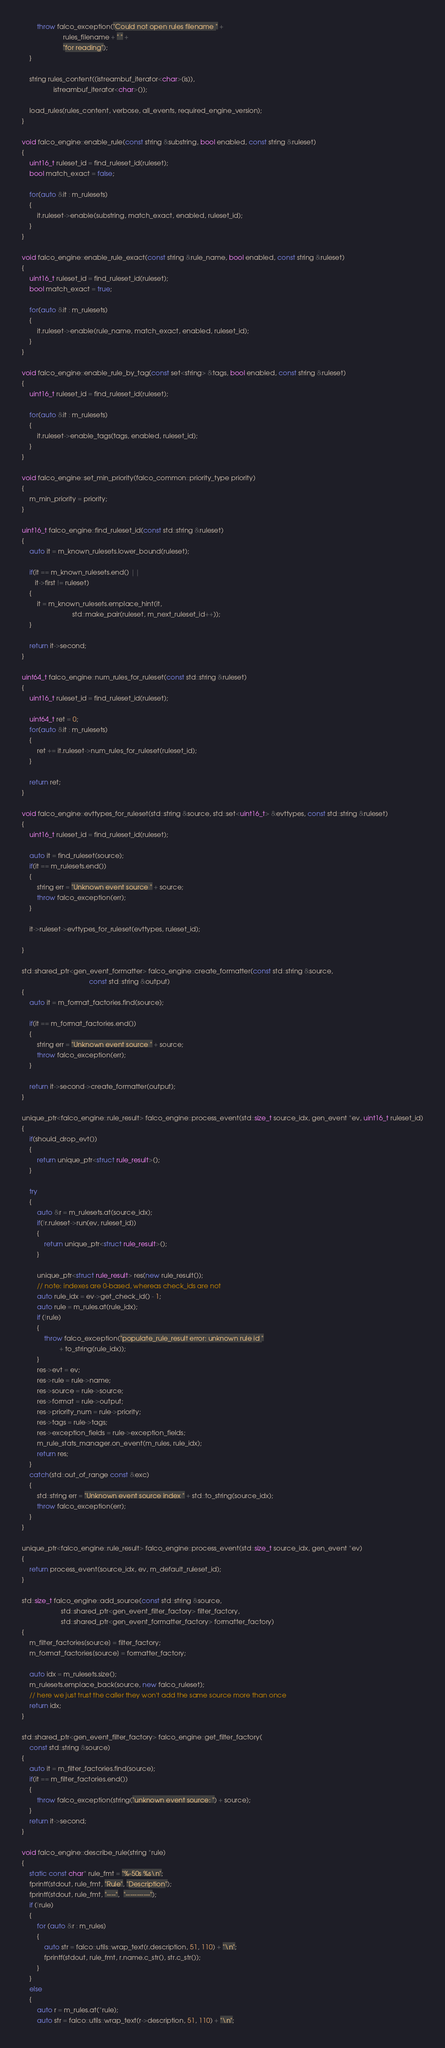Convert code to text. <code><loc_0><loc_0><loc_500><loc_500><_C++_>		throw falco_exception("Could not open rules filename " +
				      rules_filename + " " +
				      "for reading");
	}

	string rules_content((istreambuf_iterator<char>(is)),
			     istreambuf_iterator<char>());

	load_rules(rules_content, verbose, all_events, required_engine_version);
}

void falco_engine::enable_rule(const string &substring, bool enabled, const string &ruleset)
{
	uint16_t ruleset_id = find_ruleset_id(ruleset);
	bool match_exact = false;

	for(auto &it : m_rulesets)
	{
		it.ruleset->enable(substring, match_exact, enabled, ruleset_id);
	}
}

void falco_engine::enable_rule_exact(const string &rule_name, bool enabled, const string &ruleset)
{
	uint16_t ruleset_id = find_ruleset_id(ruleset);
	bool match_exact = true;

	for(auto &it : m_rulesets)
	{
		it.ruleset->enable(rule_name, match_exact, enabled, ruleset_id);
	}
}

void falco_engine::enable_rule_by_tag(const set<string> &tags, bool enabled, const string &ruleset)
{
	uint16_t ruleset_id = find_ruleset_id(ruleset);

	for(auto &it : m_rulesets)
	{
		it.ruleset->enable_tags(tags, enabled, ruleset_id);
	}
}

void falco_engine::set_min_priority(falco_common::priority_type priority)
{
	m_min_priority = priority;
}

uint16_t falco_engine::find_ruleset_id(const std::string &ruleset)
{
	auto it = m_known_rulesets.lower_bound(ruleset);

	if(it == m_known_rulesets.end() ||
	   it->first != ruleset)
	{
		it = m_known_rulesets.emplace_hint(it,
						   std::make_pair(ruleset, m_next_ruleset_id++));
	}

	return it->second;
}

uint64_t falco_engine::num_rules_for_ruleset(const std::string &ruleset)
{
	uint16_t ruleset_id = find_ruleset_id(ruleset);

	uint64_t ret = 0;
	for(auto &it : m_rulesets)
	{
		ret += it.ruleset->num_rules_for_ruleset(ruleset_id);
	}

	return ret;
}

void falco_engine::evttypes_for_ruleset(std::string &source, std::set<uint16_t> &evttypes, const std::string &ruleset)
{
	uint16_t ruleset_id = find_ruleset_id(ruleset);

	auto it = find_ruleset(source);
	if(it == m_rulesets.end())
	{
		string err = "Unknown event source " + source;
		throw falco_exception(err);
	}

	it->ruleset->evttypes_for_ruleset(evttypes, ruleset_id);

}

std::shared_ptr<gen_event_formatter> falco_engine::create_formatter(const std::string &source,
								    const std::string &output)
{
	auto it = m_format_factories.find(source);

	if(it == m_format_factories.end())
	{
		string err = "Unknown event source " + source;
		throw falco_exception(err);
	}

	return it->second->create_formatter(output);
}

unique_ptr<falco_engine::rule_result> falco_engine::process_event(std::size_t source_idx, gen_event *ev, uint16_t ruleset_id)
{
	if(should_drop_evt())
	{
		return unique_ptr<struct rule_result>();
	}

	try
	{
		auto &r = m_rulesets.at(source_idx);
		if(!r.ruleset->run(ev, ruleset_id))
		{
			return unique_ptr<struct rule_result>();
		}

		unique_ptr<struct rule_result> res(new rule_result());
		// note: indexes are 0-based, whereas check_ids are not
		auto rule_idx = ev->get_check_id() - 1;
		auto rule = m_rules.at(rule_idx);
		if (!rule)
		{
			throw falco_exception("populate_rule_result error: unknown rule id "
					+ to_string(rule_idx));
		}
		res->evt = ev;
		res->rule = rule->name;
		res->source = rule->source;
		res->format = rule->output;
		res->priority_num = rule->priority;
		res->tags = rule->tags;
		res->exception_fields = rule->exception_fields;
		m_rule_stats_manager.on_event(m_rules, rule_idx);
		return res;
	}
	catch(std::out_of_range const &exc)
	{
		std::string err = "Unknown event source index " + std::to_string(source_idx);
		throw falco_exception(err);
	}
}

unique_ptr<falco_engine::rule_result> falco_engine::process_event(std::size_t source_idx, gen_event *ev)
{
	return process_event(source_idx, ev, m_default_ruleset_id);
}

std::size_t falco_engine::add_source(const std::string &source,
				     std::shared_ptr<gen_event_filter_factory> filter_factory,
				     std::shared_ptr<gen_event_formatter_factory> formatter_factory)
{
	m_filter_factories[source] = filter_factory;
	m_format_factories[source] = formatter_factory;

	auto idx = m_rulesets.size();
	m_rulesets.emplace_back(source, new falco_ruleset);
	// here we just trust the caller they won't add the same source more than once
	return idx;
}

std::shared_ptr<gen_event_filter_factory> falco_engine::get_filter_factory(
	const std::string &source)
{
	auto it = m_filter_factories.find(source);
	if(it == m_filter_factories.end())
	{
		throw falco_exception(string("unknown event source: ") + source);
	}
	return it->second;
}

void falco_engine::describe_rule(string *rule)
{
	static const char* rule_fmt = "%-50s %s\n";
	fprintf(stdout, rule_fmt, "Rule", "Description");
	fprintf(stdout, rule_fmt, "----",  "-----------");
	if (!rule)
	{
		for (auto &r : m_rules)
		{
			auto str = falco::utils::wrap_text(r.description, 51, 110) + "\n";
			fprintf(stdout, rule_fmt, r.name.c_str(), str.c_str());
		}
	}
	else
	{
		auto r = m_rules.at(*rule);
		auto str = falco::utils::wrap_text(r->description, 51, 110) + "\n";</code> 